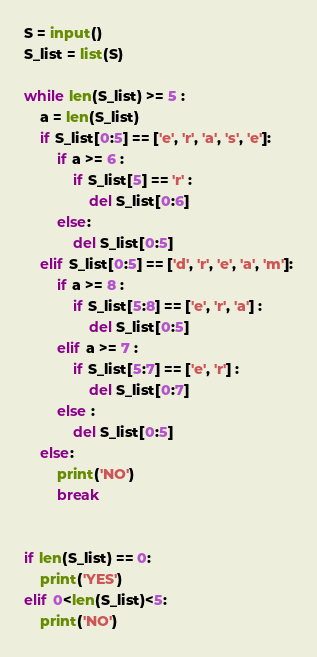<code> <loc_0><loc_0><loc_500><loc_500><_Python_>S = input()
S_list = list(S)

while len(S_list) >= 5 :
    a = len(S_list)
    if S_list[0:5] == ['e', 'r', 'a', 's', 'e']:
        if a >= 6 :
            if S_list[5] == 'r' :
                del S_list[0:6]
        else:
            del S_list[0:5]
    elif S_list[0:5] == ['d', 'r', 'e', 'a', 'm']:
        if a >= 8 :
            if S_list[5:8] == ['e', 'r', 'a'] :
                del S_list[0:5]
        elif a >= 7 :
            if S_list[5:7] == ['e', 'r'] :
                del S_list[0:7]
        else :
            del S_list[0:5]
    else:
        print('NO')
        break


if len(S_list) == 0:
    print('YES')
elif 0<len(S_list)<5:
    print('NO')</code> 